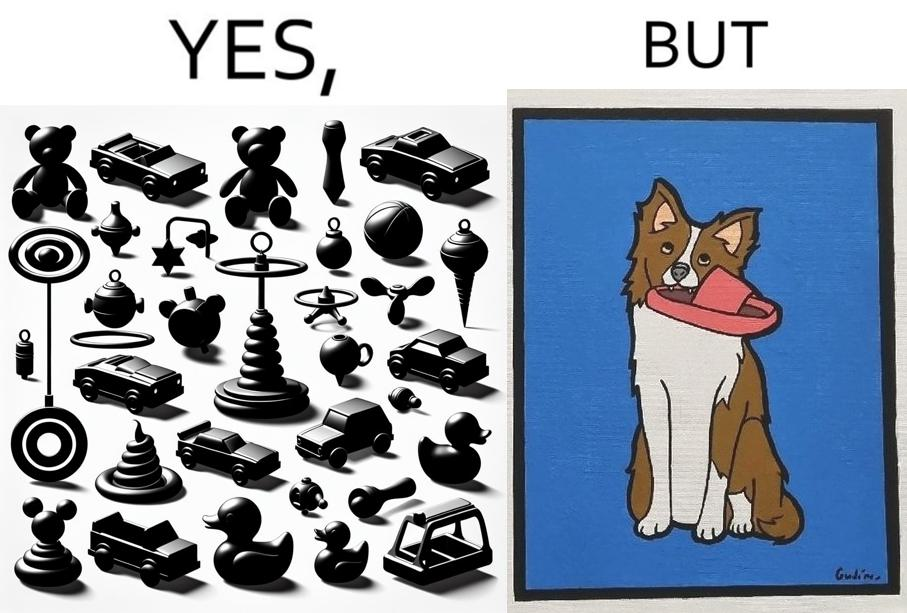Explain why this image is satirical. the irony is that dog owners buy loads of toys for their dog but the dog's favourite toy is the owner's slippers 